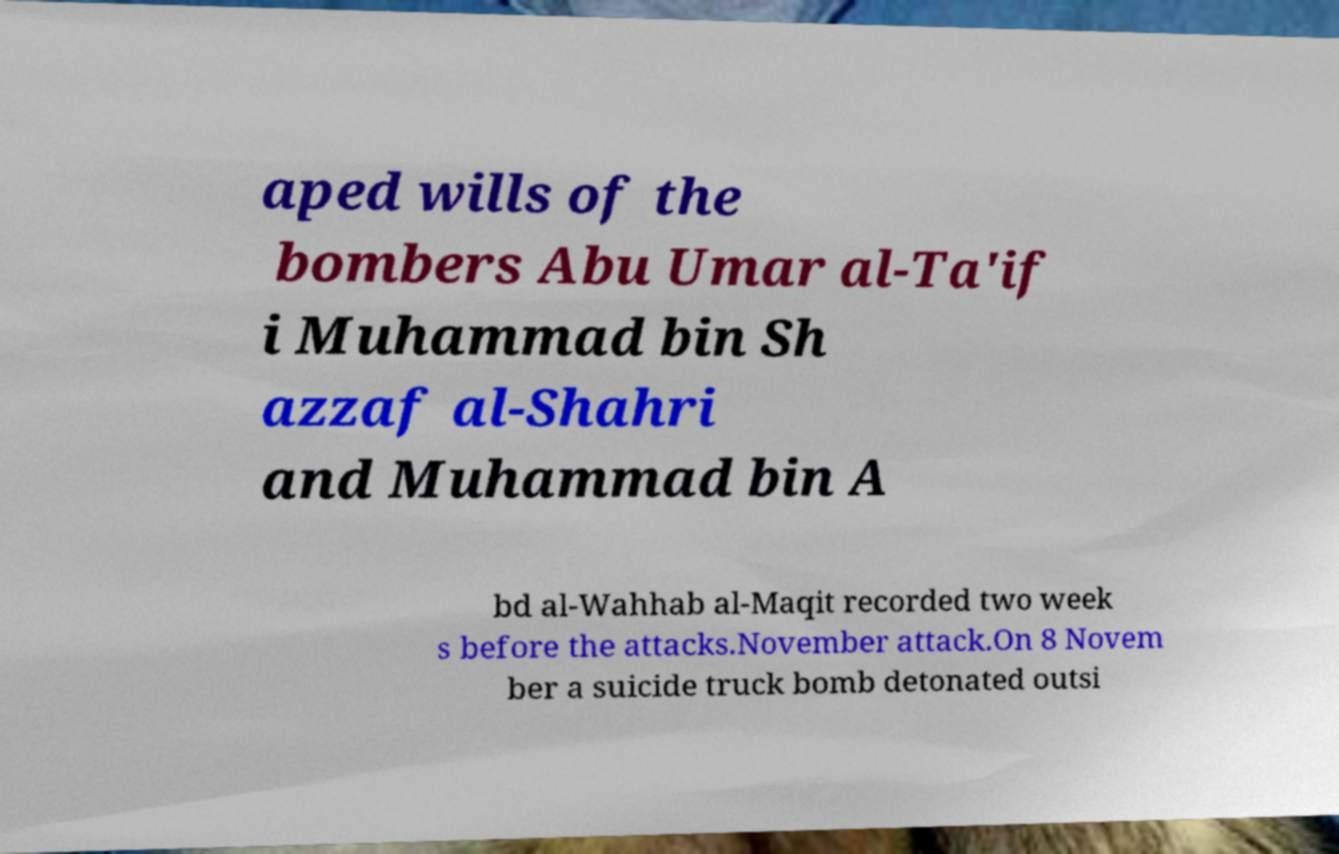Could you assist in decoding the text presented in this image and type it out clearly? aped wills of the bombers Abu Umar al-Ta'if i Muhammad bin Sh azzaf al-Shahri and Muhammad bin A bd al-Wahhab al-Maqit recorded two week s before the attacks.November attack.On 8 Novem ber a suicide truck bomb detonated outsi 